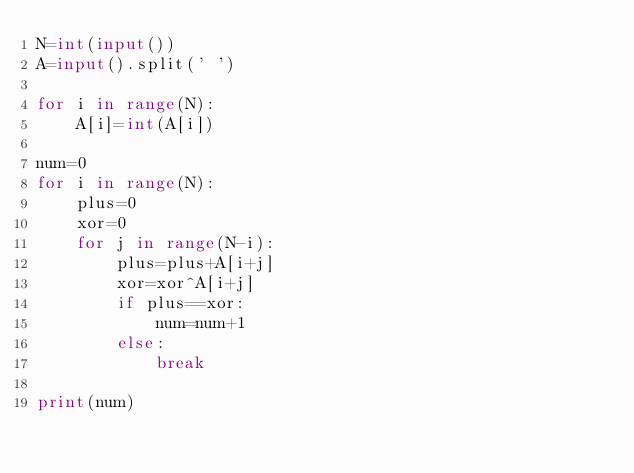Convert code to text. <code><loc_0><loc_0><loc_500><loc_500><_Python_>N=int(input())
A=input().split(' ')

for i in range(N):
	A[i]=int(A[i])

num=0
for i in range(N):
	plus=0
	xor=0
	for j in range(N-i):
		plus=plus+A[i+j]
		xor=xor^A[i+j]
		if plus==xor:
			num=num+1
		else:
			break

print(num)
</code> 